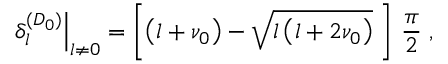<formula> <loc_0><loc_0><loc_500><loc_500>\delta _ { l } ^ { ( D _ { 0 } ) } \right | _ { l \neq 0 } = \left [ \left ( l + \nu _ { 0 } \right ) - \sqrt { l \left ( l + 2 \nu _ { 0 } \right ) } \, \right ] \, \frac { \pi } { 2 } \, ,</formula> 